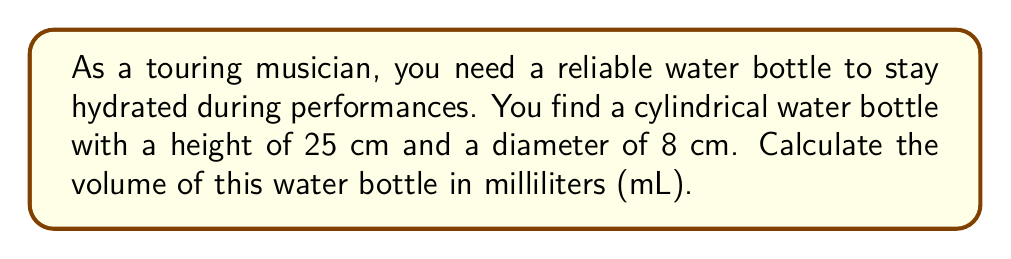Show me your answer to this math problem. To calculate the volume of a cylindrical water bottle, we need to use the formula for the volume of a cylinder:

$$V = \pi r^2 h$$

Where:
$V$ = volume
$r$ = radius of the base
$h$ = height of the cylinder

Given:
- Height (h) = 25 cm
- Diameter = 8 cm

Step 1: Calculate the radius
The radius is half the diameter:
$r = 8 \text{ cm} \div 2 = 4 \text{ cm}$

Step 2: Apply the volume formula
$$V = \pi (4 \text{ cm})^2 (25 \text{ cm})$$

Step 3: Simplify the calculation
$$V = \pi (16 \text{ cm}^2) (25 \text{ cm})$$
$$V = 400\pi \text{ cm}^3$$

Step 4: Calculate the approximate value
$$V \approx 1256.64 \text{ cm}^3$$

Step 5: Convert cubic centimeters to milliliters
Since 1 cm³ = 1 mL, the volume in milliliters is the same as the volume in cubic centimeters.

$$V \approx 1256.64 \text{ mL}$$

Round to the nearest mL:
$$V \approx 1257 \text{ mL}$$
Answer: 1257 mL 